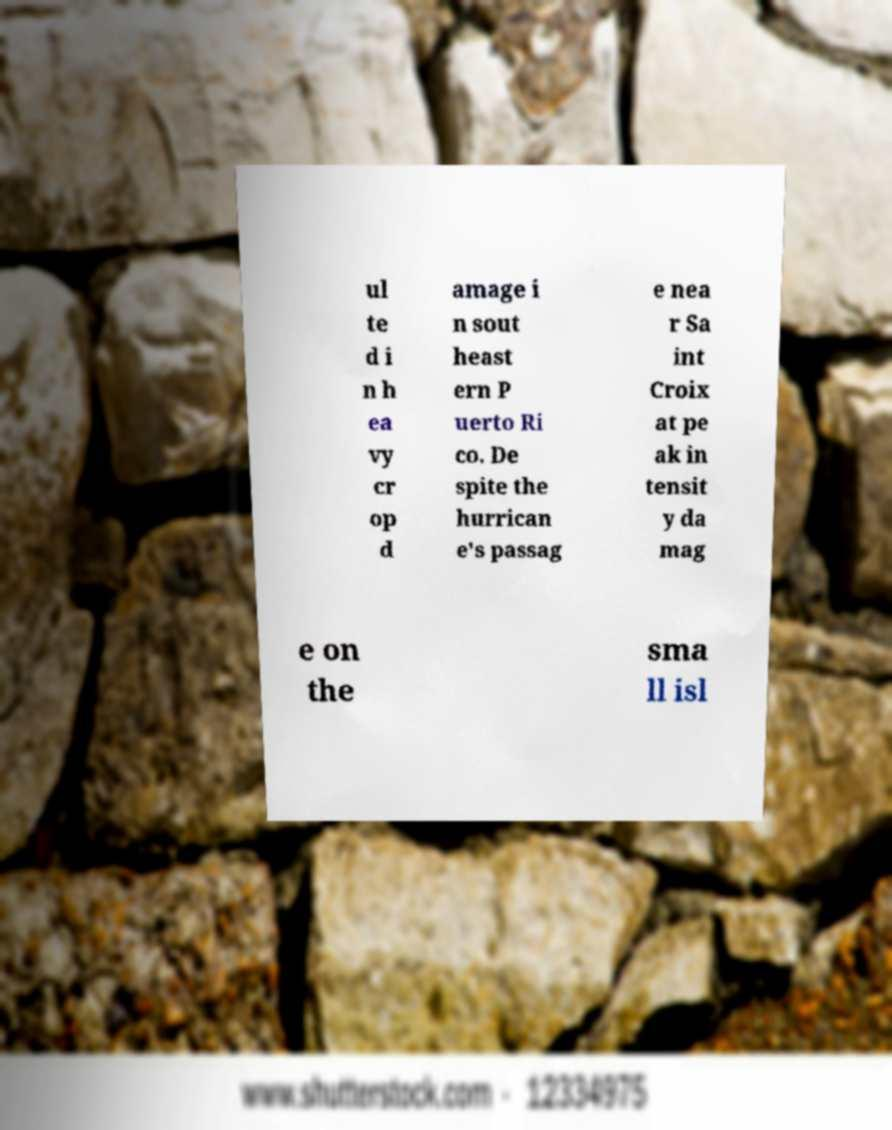For documentation purposes, I need the text within this image transcribed. Could you provide that? ul te d i n h ea vy cr op d amage i n sout heast ern P uerto Ri co. De spite the hurrican e's passag e nea r Sa int Croix at pe ak in tensit y da mag e on the sma ll isl 